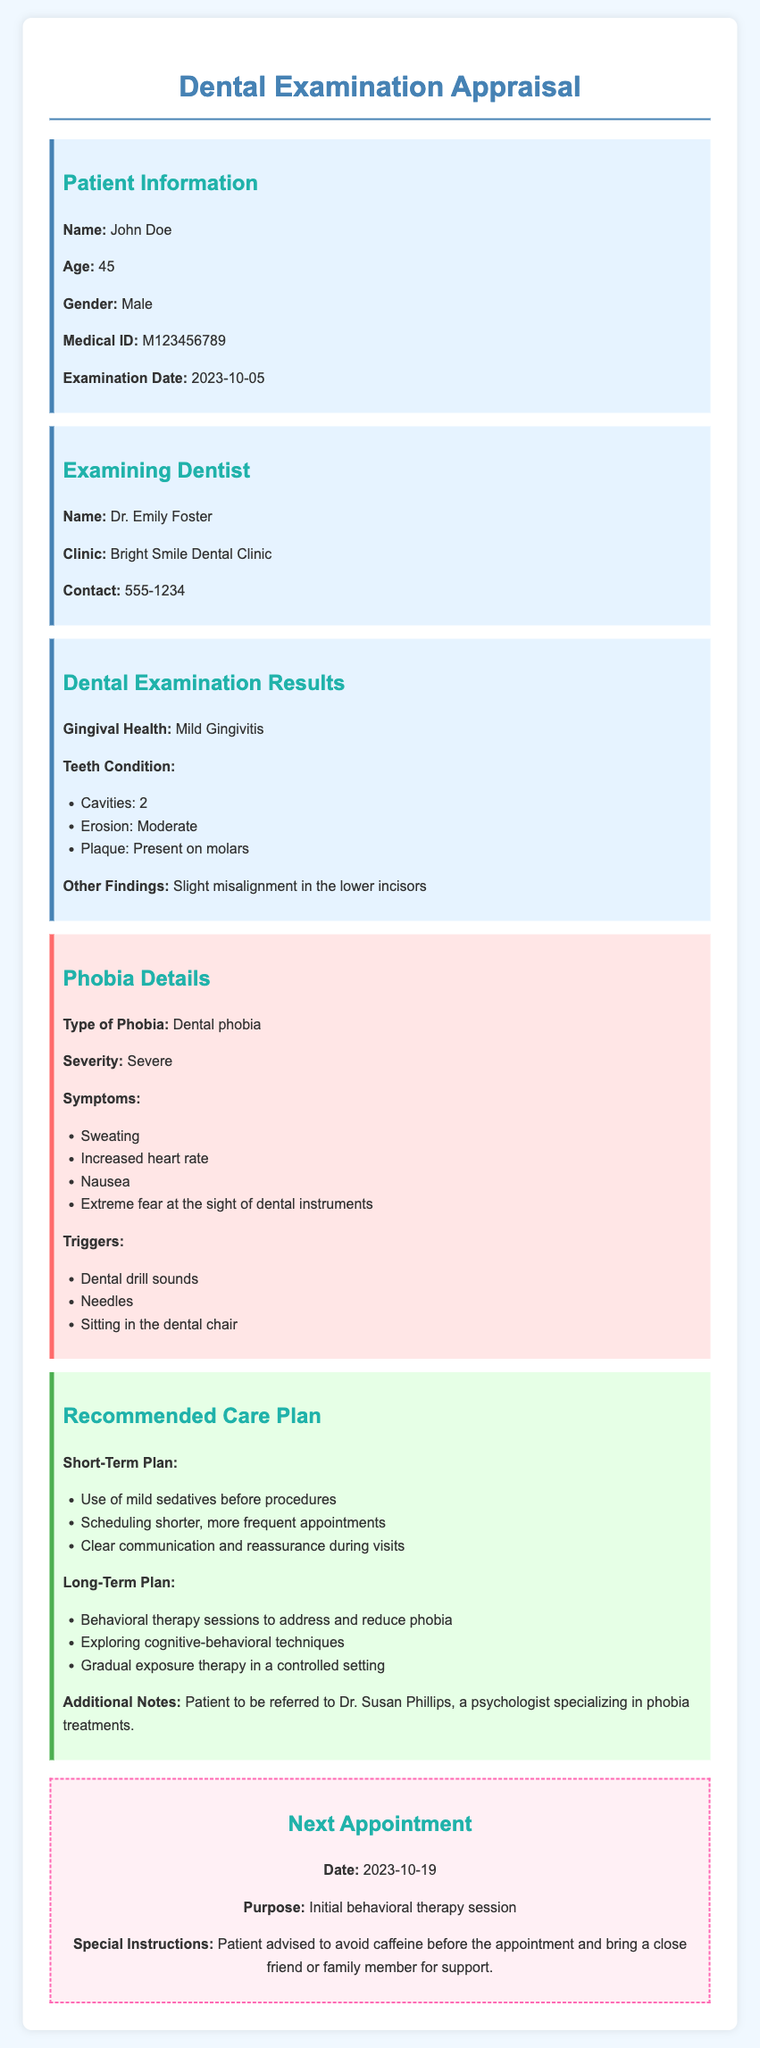what is the patient's name? The patient's name is listed under Patient Information in the document.
Answer: John Doe what is the examination date? The examination date is provided in the Patient Information section of the document.
Answer: 2023-10-05 what is the name of the examining dentist? The name of the examining dentist is found in the Examining Dentist section.
Answer: Dr. Emily Foster how many cavities were found during the examination? The number of cavities is specified in the Dental Examination Results section.
Answer: 2 what is the severity of the patient's dental phobia? The severity of the patient's phobia is mentioned in the Phobia Details section.
Answer: Severe what are two triggers for the patient's dental phobia? The triggers for the patient's phobia are listed in the Phobia Details section.
Answer: Dental drill sounds, Needles what is one component of the short-term care plan? One component of the short-term care plan is described in the Recommended Care Plan section.
Answer: Use of mild sedatives before procedures who is the patient referred to for behavioral therapy? The referral for behavioral therapy is mentioned in the Recommended Care Plan section.
Answer: Dr. Susan Phillips when is the next appointment scheduled? The date of the next appointment is stated in the Next Appointment section.
Answer: 2023-10-19 what is the purpose of the next appointment? The purpose of the next appointment is indicated in the Next Appointment section.
Answer: Initial behavioral therapy session 